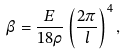Convert formula to latex. <formula><loc_0><loc_0><loc_500><loc_500>\ \beta = \frac { E } { 1 8 \rho } \left ( \frac { 2 \pi } { l } \right ) ^ { 4 } ,</formula> 